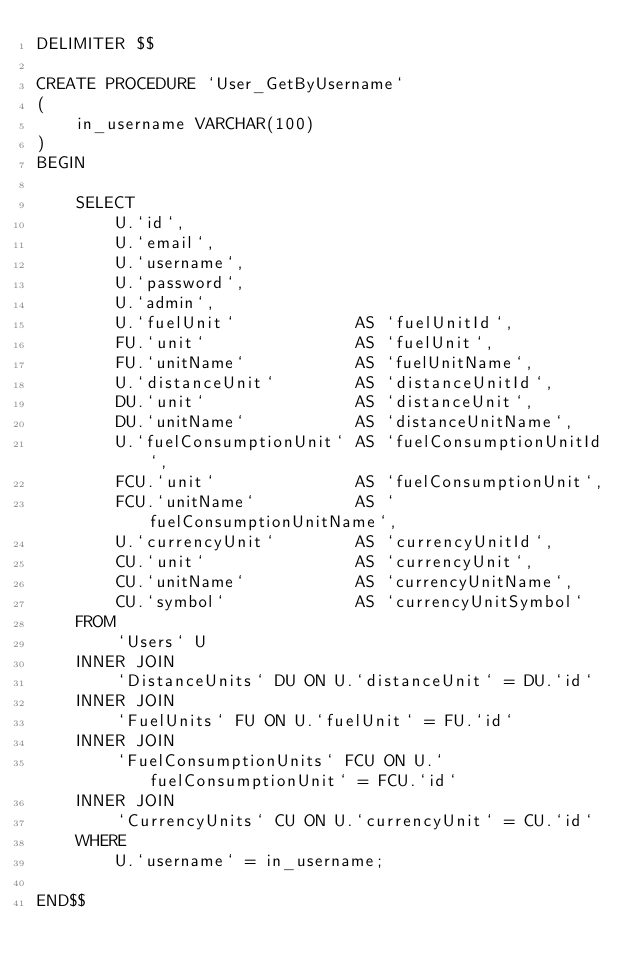<code> <loc_0><loc_0><loc_500><loc_500><_SQL_>DELIMITER $$

CREATE PROCEDURE `User_GetByUsername`
(
    in_username VARCHAR(100)
)
BEGIN

    SELECT
        U.`id`,
        U.`email`,
        U.`username`,
        U.`password`,
        U.`admin`,
        U.`fuelUnit`            AS `fuelUnitId`,
        FU.`unit` 		        AS `fuelUnit`,
        FU.`unitName` 	        AS `fuelUnitName`,
        U.`distanceUnit`        AS `distanceUnitId`,
        DU.`unit` 		        AS `distanceUnit`,
        DU.`unitName` 	        AS `distanceUnitName`,
        U.`fuelConsumptionUnit` AS `fuelConsumptionUnitId`,
        FCU.`unit` 		        AS `fuelConsumptionUnit`,
        FCU.`unitName`          AS `fuelConsumptionUnitName`,
        U.`currencyUnit`        AS `currencyUnitId`,
        CU.`unit`               AS `currencyUnit`,
        CU.`unitName`           AS `currencyUnitName`,
        CU.`symbol`             AS `currencyUnitSymbol`
    FROM
        `Users` U
    INNER JOIN
        `DistanceUnits` DU ON U.`distanceUnit` = DU.`id`
    INNER JOIN
        `FuelUnits` FU ON U.`fuelUnit` = FU.`id`
    INNER JOIN
        `FuelConsumptionUnits` FCU ON U.`fuelConsumptionUnit` = FCU.`id`
    INNER JOIN
        `CurrencyUnits` CU ON U.`currencyUnit` = CU.`id`
    WHERE
        U.`username` = in_username;

END$$
</code> 